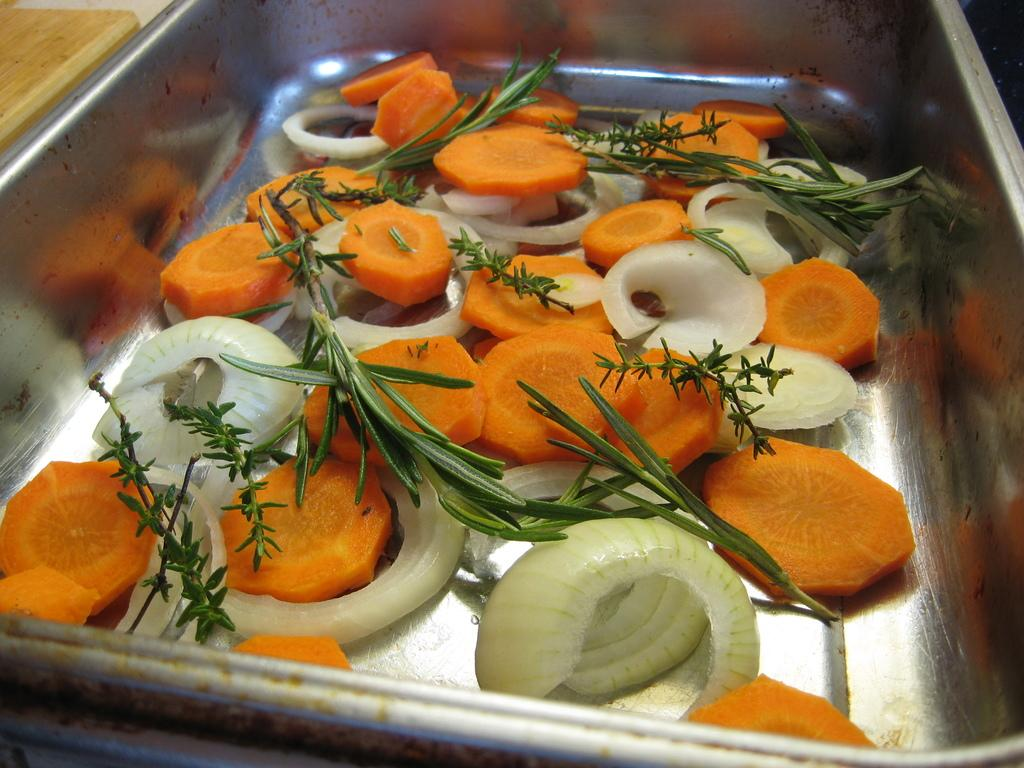What type of vegetables can be seen in the image? There are slices of carrot and onion in the image. What else is present in the image besides the vegetables? There is green salad in the image. How are the vegetables and salad arranged in the image? The slices of carrot, onion, and green salad are in a tray. How does the crowd react to the sea in the image? There is no crowd or sea present in the image; it features slices of carrot, onion, and green salad in a tray. What type of mask is being worn by the vegetables in the image? There are no masks present in the image; it features slices of carrot, onion, and green salad in a tray. 